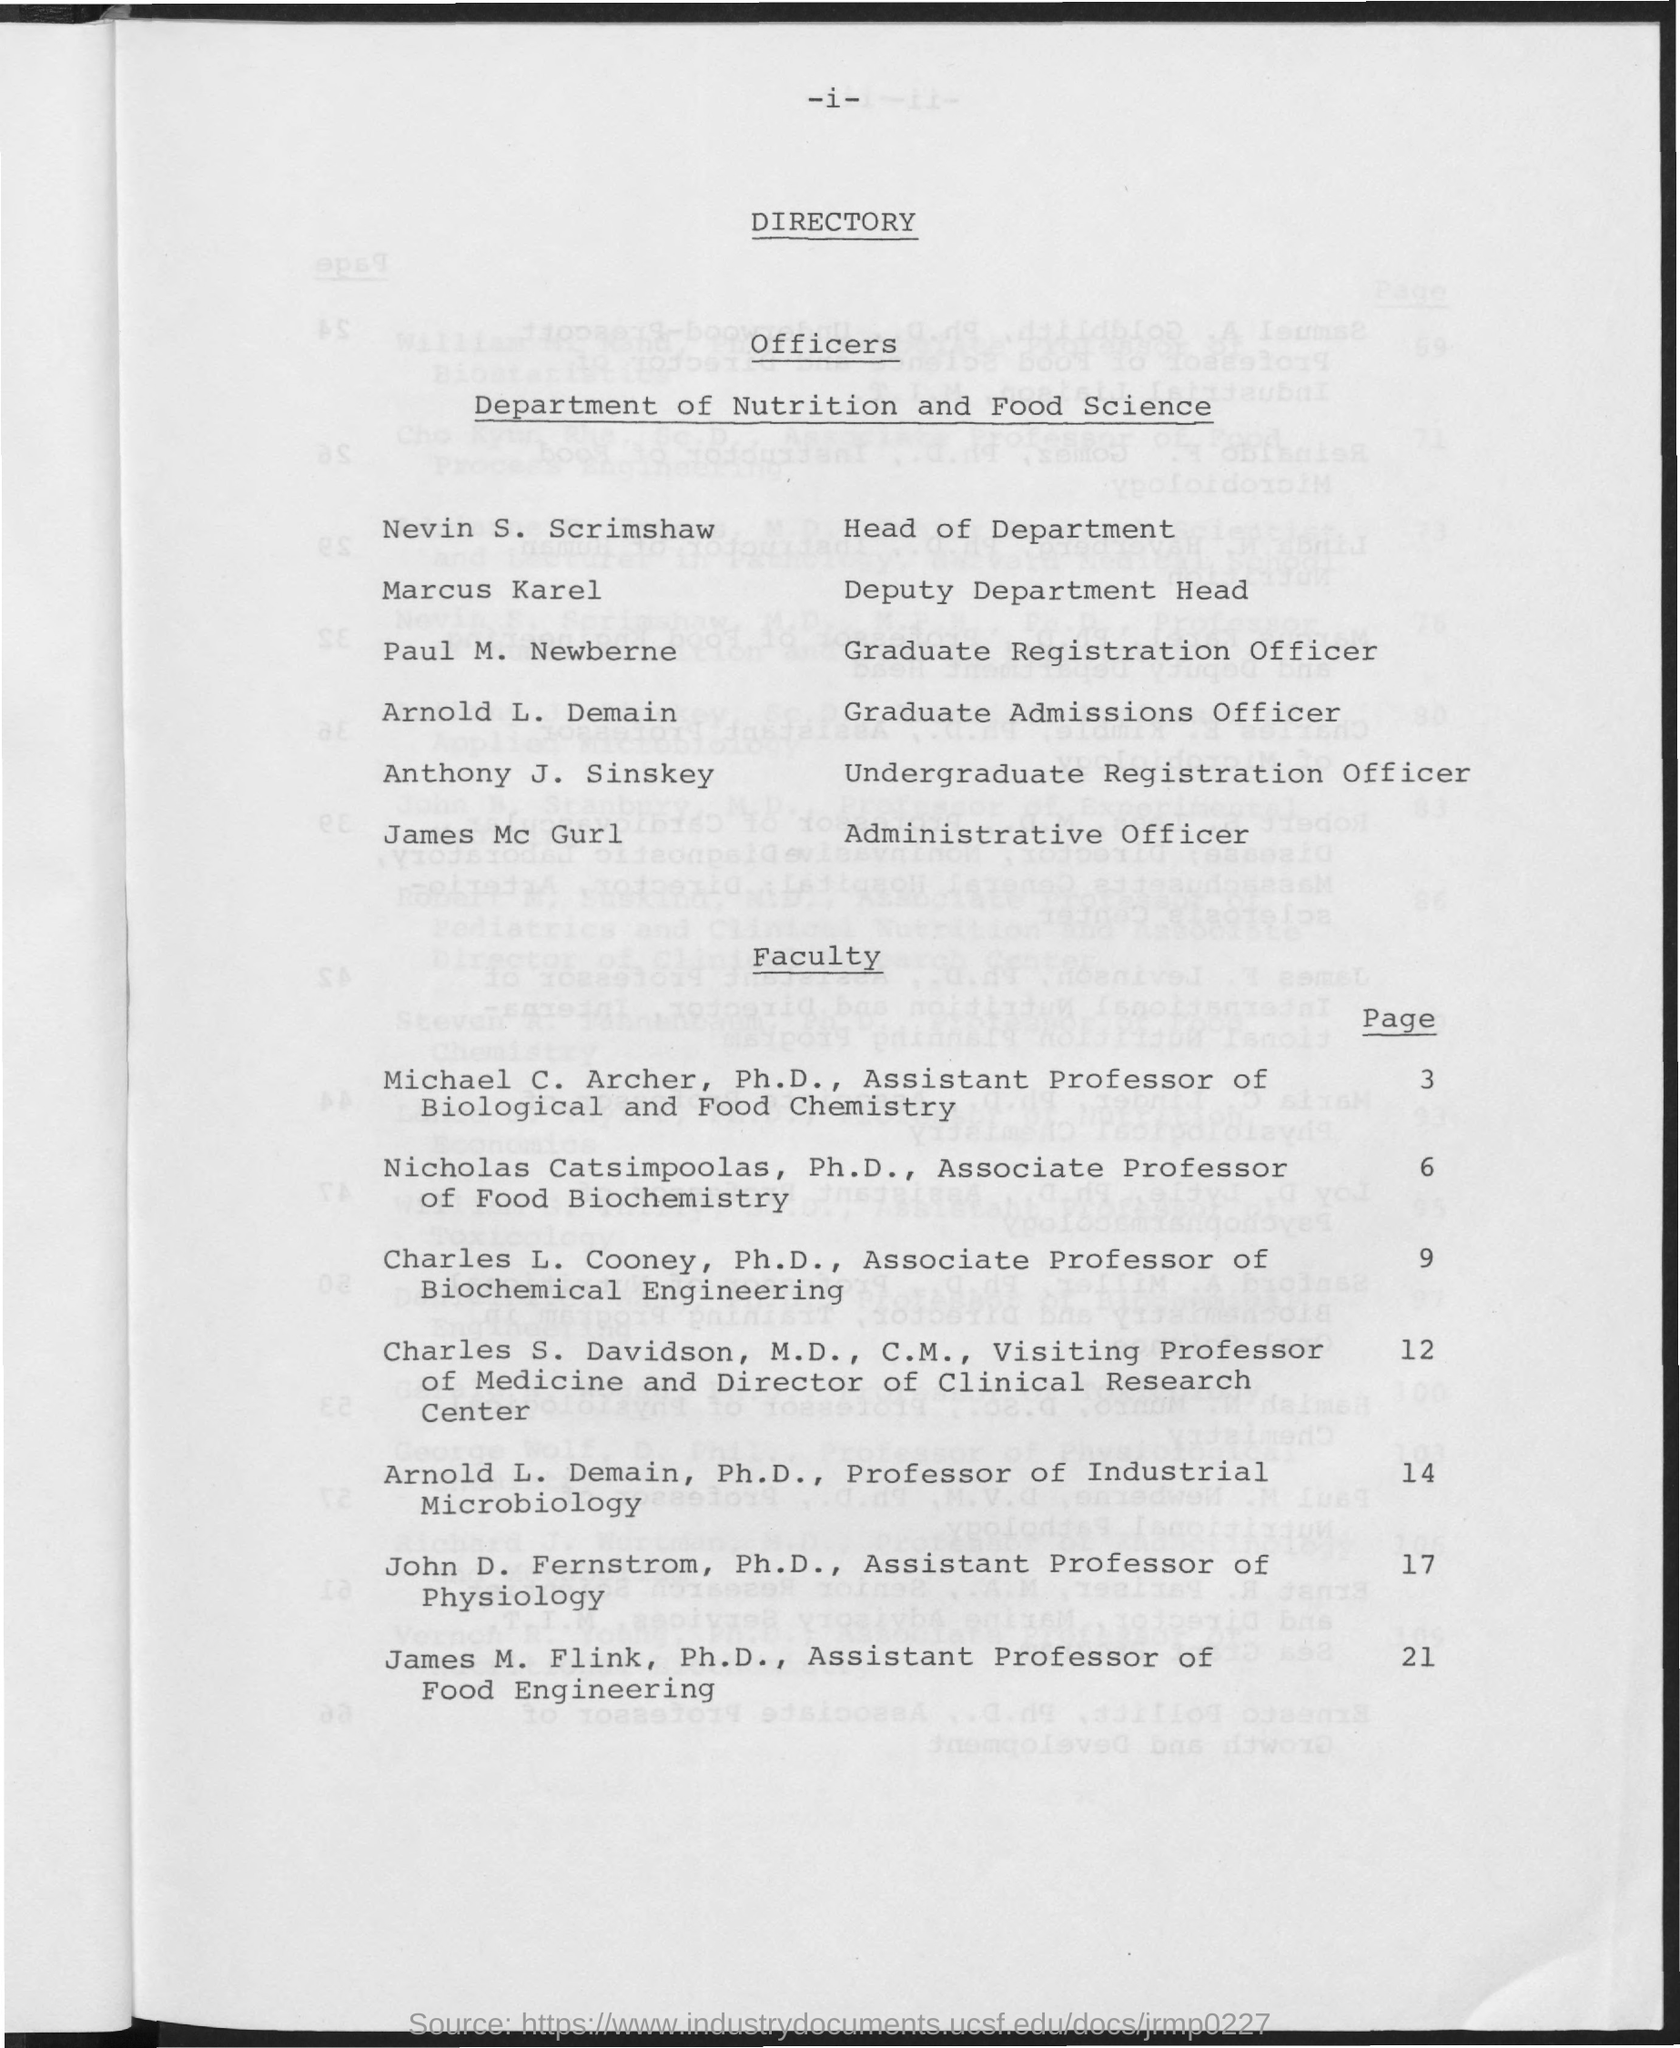Who is the Head of Department ?
Offer a very short reply. Nevin S. Scrimshaw. What is the Page number for faculty Arnold L. Demain ?
Your response must be concise. 14. Who is the Deputy Department Head ?
Ensure brevity in your answer.  Marcus Karel. 